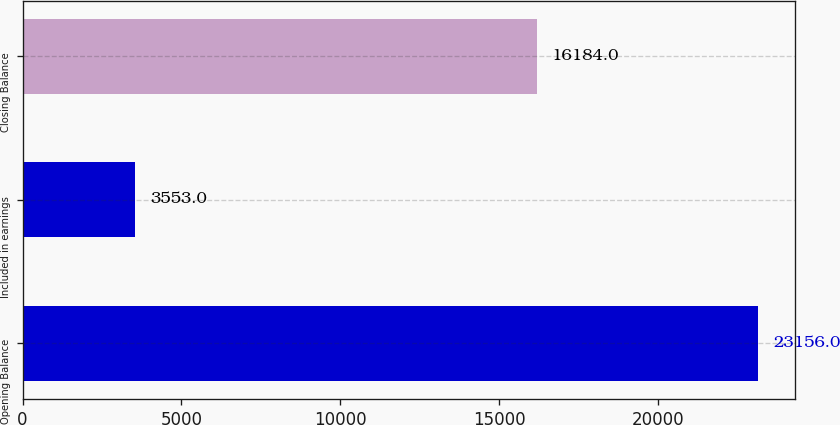<chart> <loc_0><loc_0><loc_500><loc_500><bar_chart><fcel>Opening Balance<fcel>Included in earnings<fcel>Closing Balance<nl><fcel>23156<fcel>3553<fcel>16184<nl></chart> 